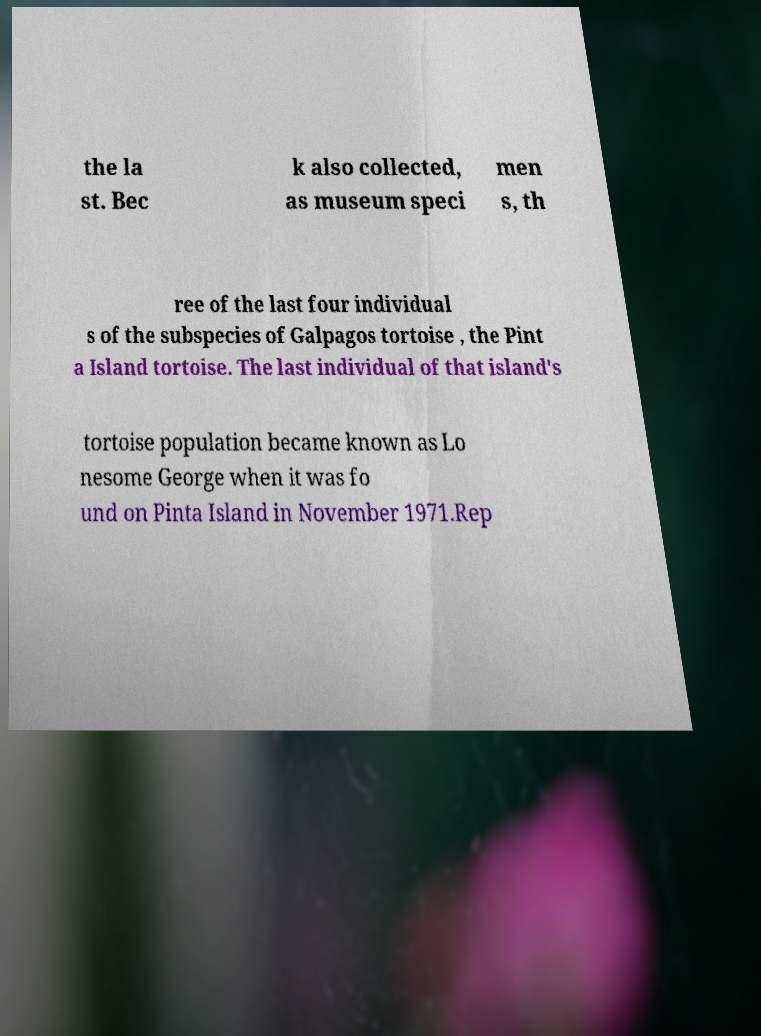Can you accurately transcribe the text from the provided image for me? the la st. Bec k also collected, as museum speci men s, th ree of the last four individual s of the subspecies of Galpagos tortoise , the Pint a Island tortoise. The last individual of that island's tortoise population became known as Lo nesome George when it was fo und on Pinta Island in November 1971.Rep 